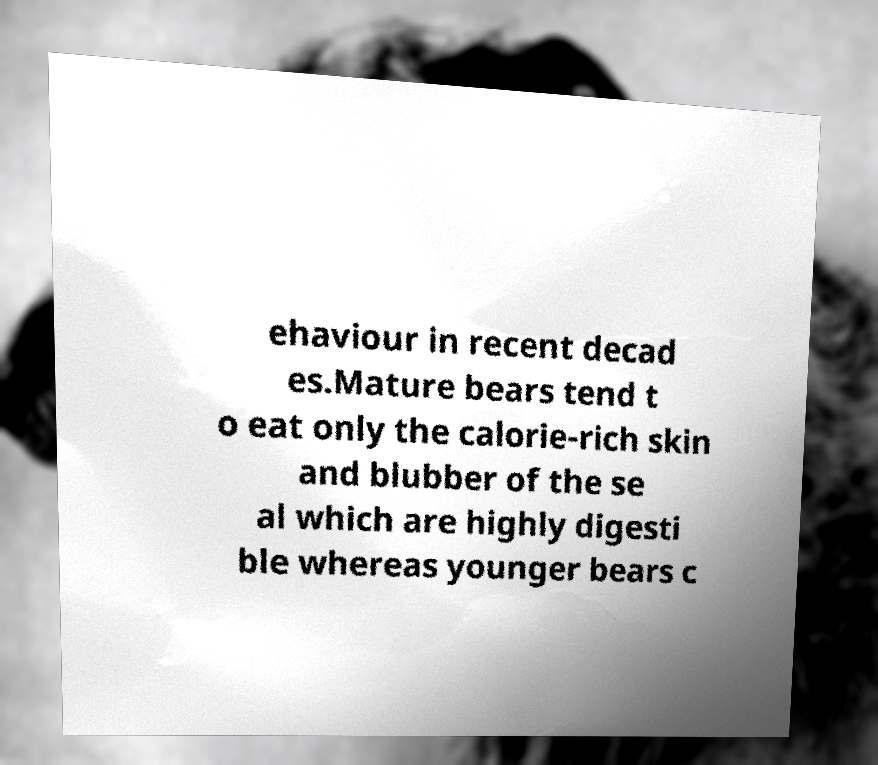Can you accurately transcribe the text from the provided image for me? ehaviour in recent decad es.Mature bears tend t o eat only the calorie-rich skin and blubber of the se al which are highly digesti ble whereas younger bears c 